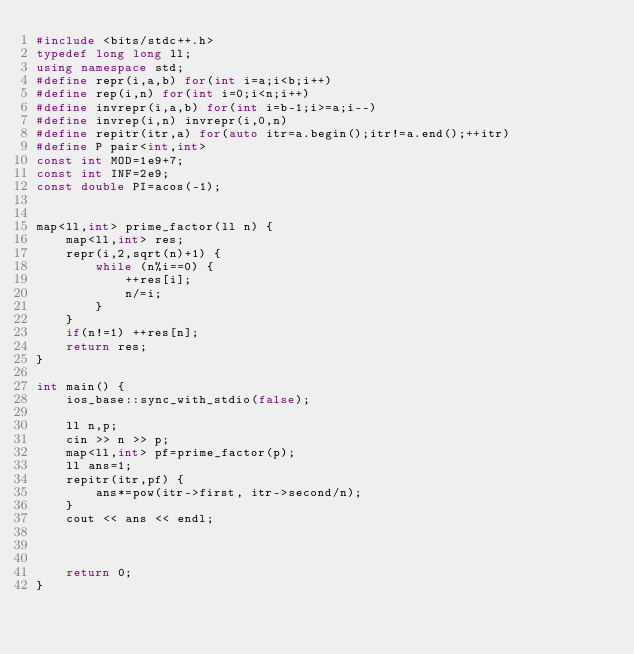<code> <loc_0><loc_0><loc_500><loc_500><_C++_>#include <bits/stdc++.h>
typedef long long ll;
using namespace std;
#define repr(i,a,b) for(int i=a;i<b;i++)
#define rep(i,n) for(int i=0;i<n;i++)
#define invrepr(i,a,b) for(int i=b-1;i>=a;i--)
#define invrep(i,n) invrepr(i,0,n)
#define repitr(itr,a) for(auto itr=a.begin();itr!=a.end();++itr)
#define P pair<int,int>
const int MOD=1e9+7;
const int INF=2e9;
const double PI=acos(-1);


map<ll,int> prime_factor(ll n) {
    map<ll,int> res;
    repr(i,2,sqrt(n)+1) {
        while (n%i==0) {
            ++res[i];
            n/=i;
        }
    }
    if(n!=1) ++res[n];
    return res;
}

int main() {
    ios_base::sync_with_stdio(false);

    ll n,p;
    cin >> n >> p;
    map<ll,int> pf=prime_factor(p);
    ll ans=1;
    repitr(itr,pf) {
        ans*=pow(itr->first, itr->second/n);
    }
    cout << ans << endl;

        
    
    return 0;   
}</code> 